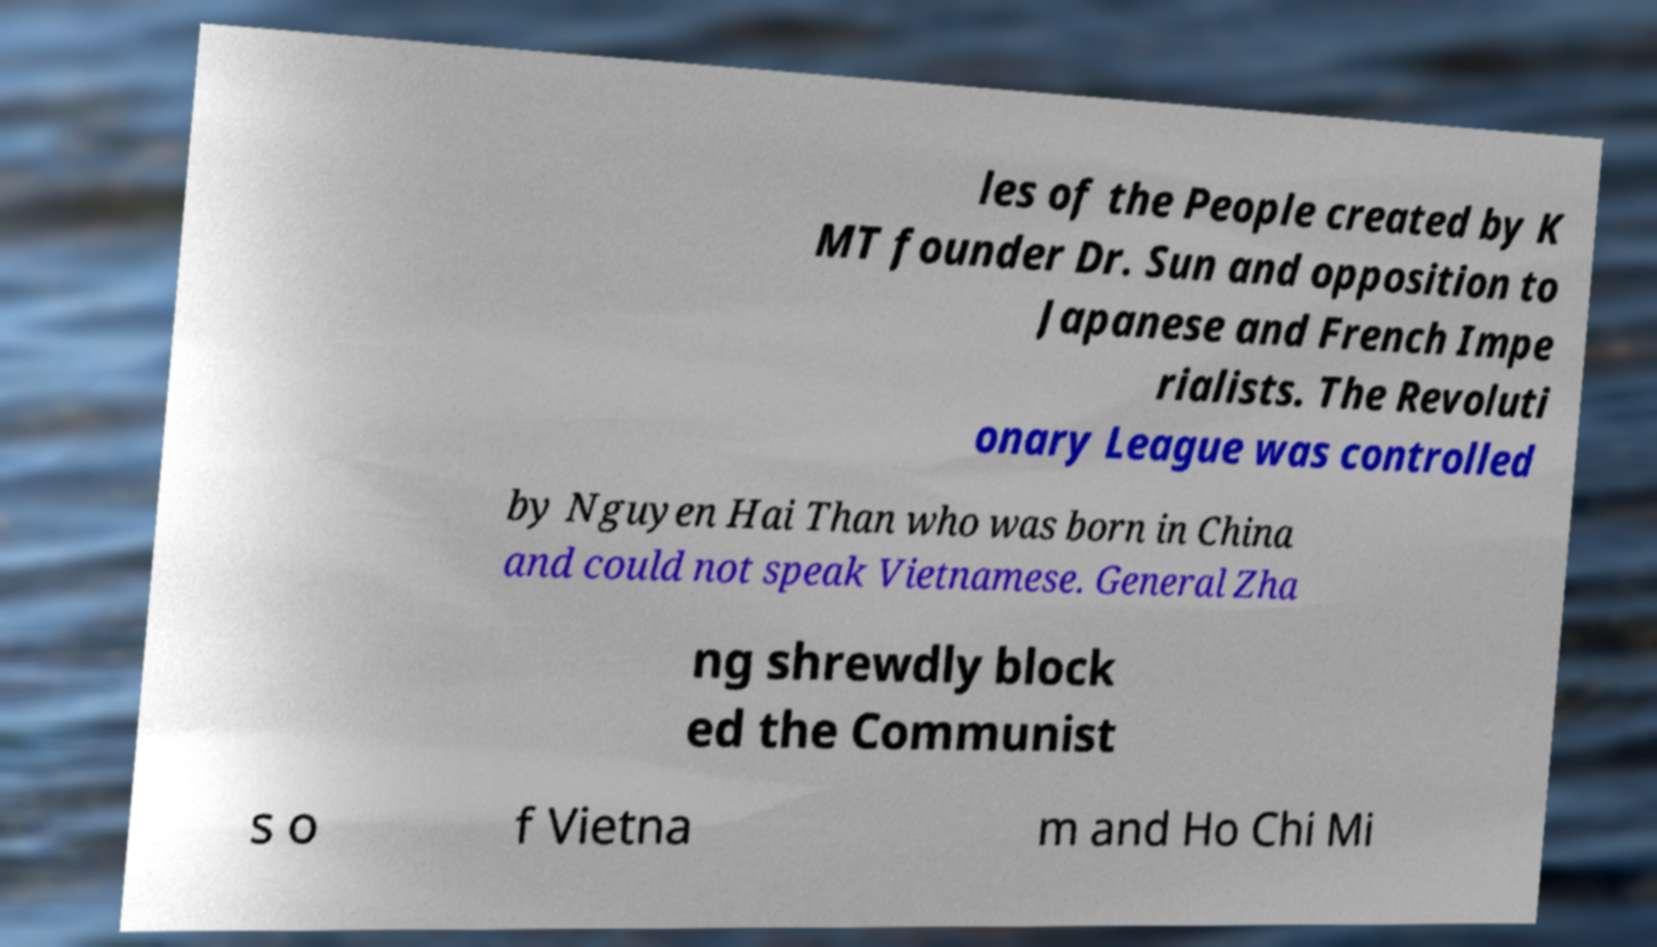Could you extract and type out the text from this image? les of the People created by K MT founder Dr. Sun and opposition to Japanese and French Impe rialists. The Revoluti onary League was controlled by Nguyen Hai Than who was born in China and could not speak Vietnamese. General Zha ng shrewdly block ed the Communist s o f Vietna m and Ho Chi Mi 